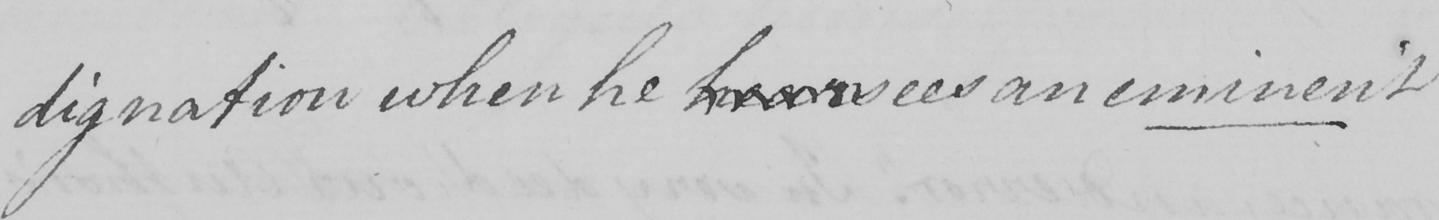Please provide the text content of this handwritten line. dignation when he hears sees an eminent 